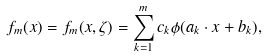Convert formula to latex. <formula><loc_0><loc_0><loc_500><loc_500>f _ { m } ( x ) = f _ { m } ( x , \zeta ) = \sum _ { k = 1 } ^ { m } c _ { k } \phi ( a _ { k } \cdot x + b _ { k } ) ,</formula> 